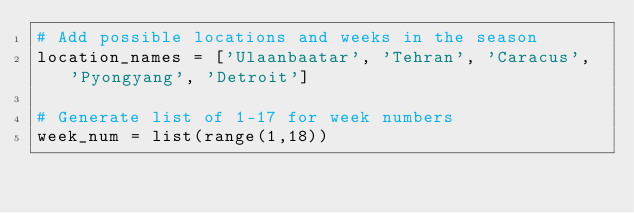<code> <loc_0><loc_0><loc_500><loc_500><_Python_># Add possible locations and weeks in the season
location_names = ['Ulaanbaatar', 'Tehran', 'Caracus', 'Pyongyang', 'Detroit']

# Generate list of 1-17 for week numbers 
week_num = list(range(1,18))</code> 